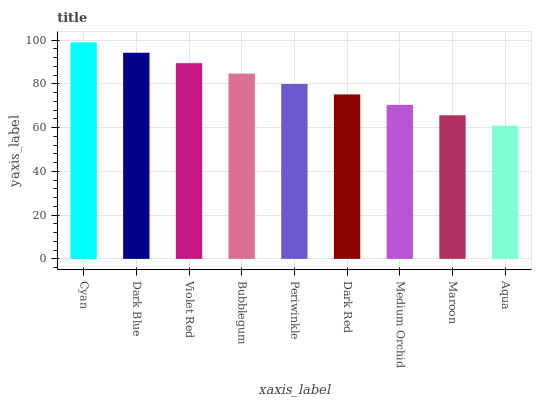Is Aqua the minimum?
Answer yes or no. Yes. Is Cyan the maximum?
Answer yes or no. Yes. Is Dark Blue the minimum?
Answer yes or no. No. Is Dark Blue the maximum?
Answer yes or no. No. Is Cyan greater than Dark Blue?
Answer yes or no. Yes. Is Dark Blue less than Cyan?
Answer yes or no. Yes. Is Dark Blue greater than Cyan?
Answer yes or no. No. Is Cyan less than Dark Blue?
Answer yes or no. No. Is Periwinkle the high median?
Answer yes or no. Yes. Is Periwinkle the low median?
Answer yes or no. Yes. Is Cyan the high median?
Answer yes or no. No. Is Bubblegum the low median?
Answer yes or no. No. 